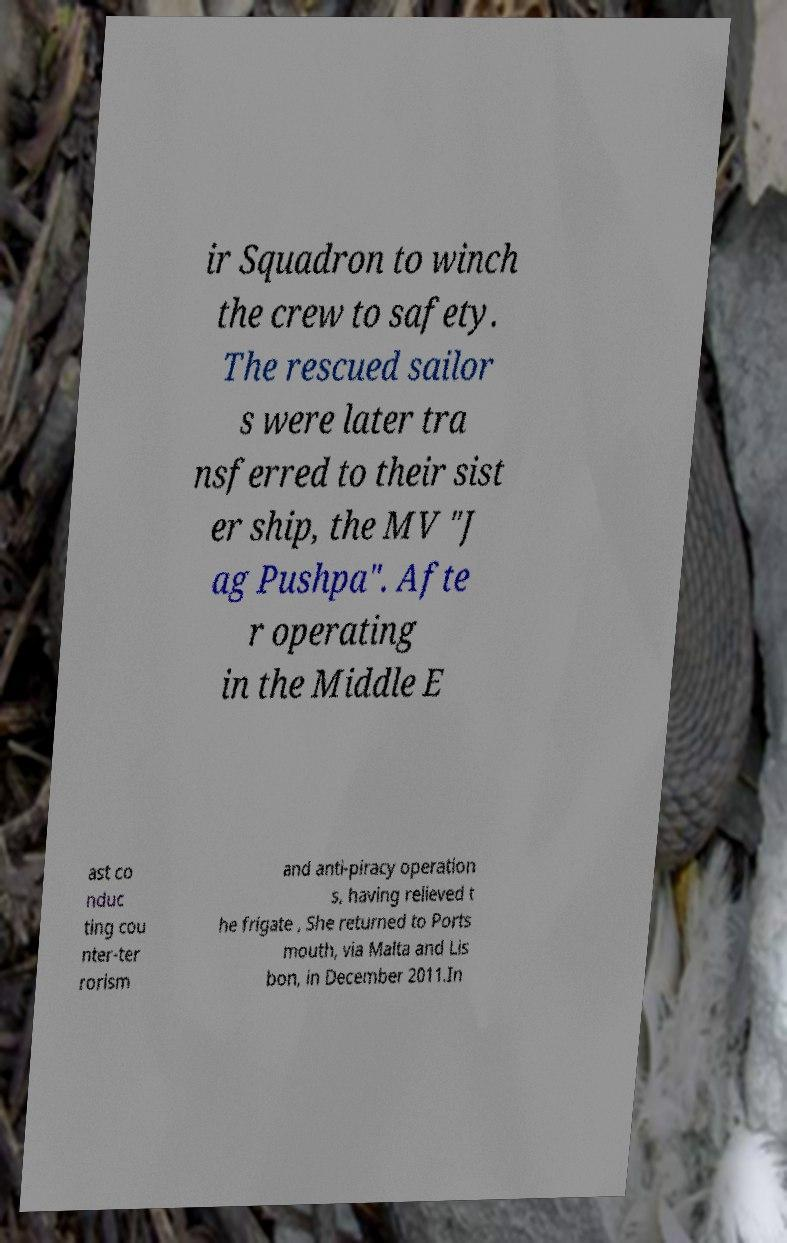What messages or text are displayed in this image? I need them in a readable, typed format. ir Squadron to winch the crew to safety. The rescued sailor s were later tra nsferred to their sist er ship, the MV "J ag Pushpa". Afte r operating in the Middle E ast co nduc ting cou nter-ter rorism and anti-piracy operation s, having relieved t he frigate , She returned to Ports mouth, via Malta and Lis bon, in December 2011.In 